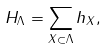Convert formula to latex. <formula><loc_0><loc_0><loc_500><loc_500>H _ { \Lambda } = \sum _ { X \subset \Lambda } h _ { X } ,</formula> 